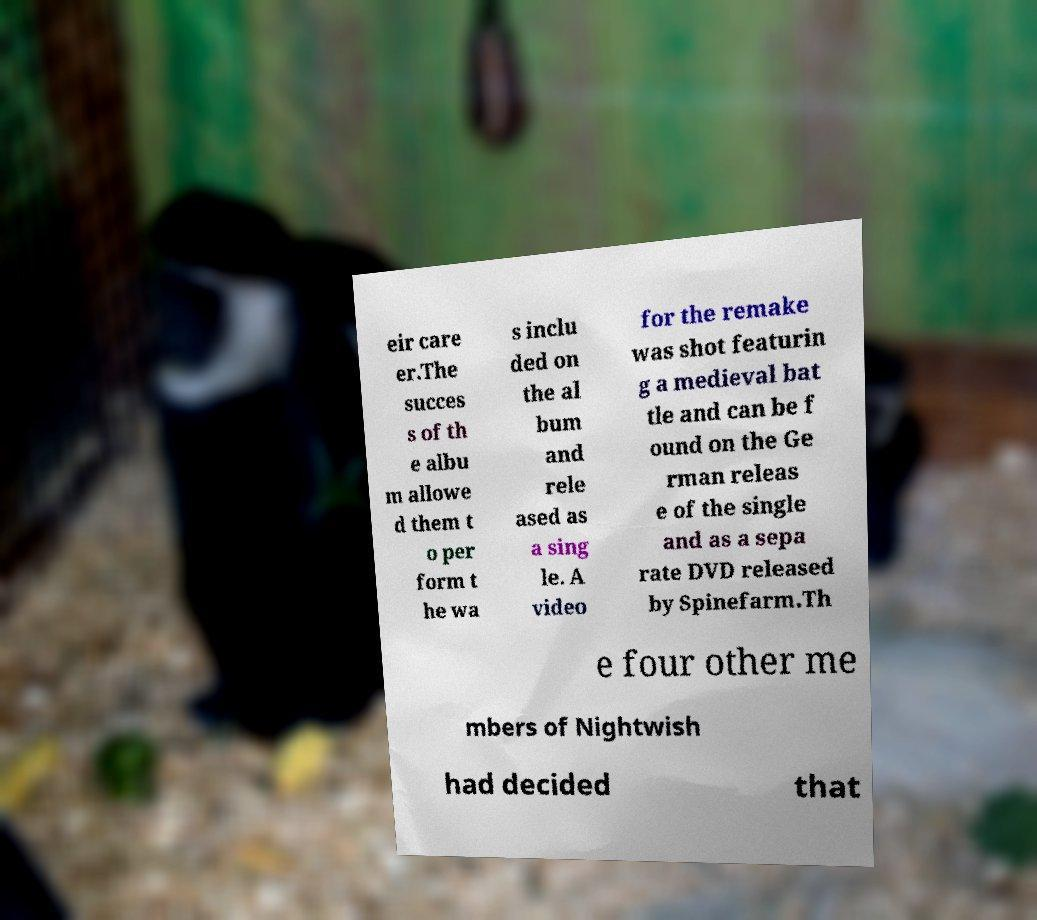Could you assist in decoding the text presented in this image and type it out clearly? eir care er.The succes s of th e albu m allowe d them t o per form t he wa s inclu ded on the al bum and rele ased as a sing le. A video for the remake was shot featurin g a medieval bat tle and can be f ound on the Ge rman releas e of the single and as a sepa rate DVD released by Spinefarm.Th e four other me mbers of Nightwish had decided that 